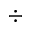Convert formula to latex. <formula><loc_0><loc_0><loc_500><loc_500>\div</formula> 